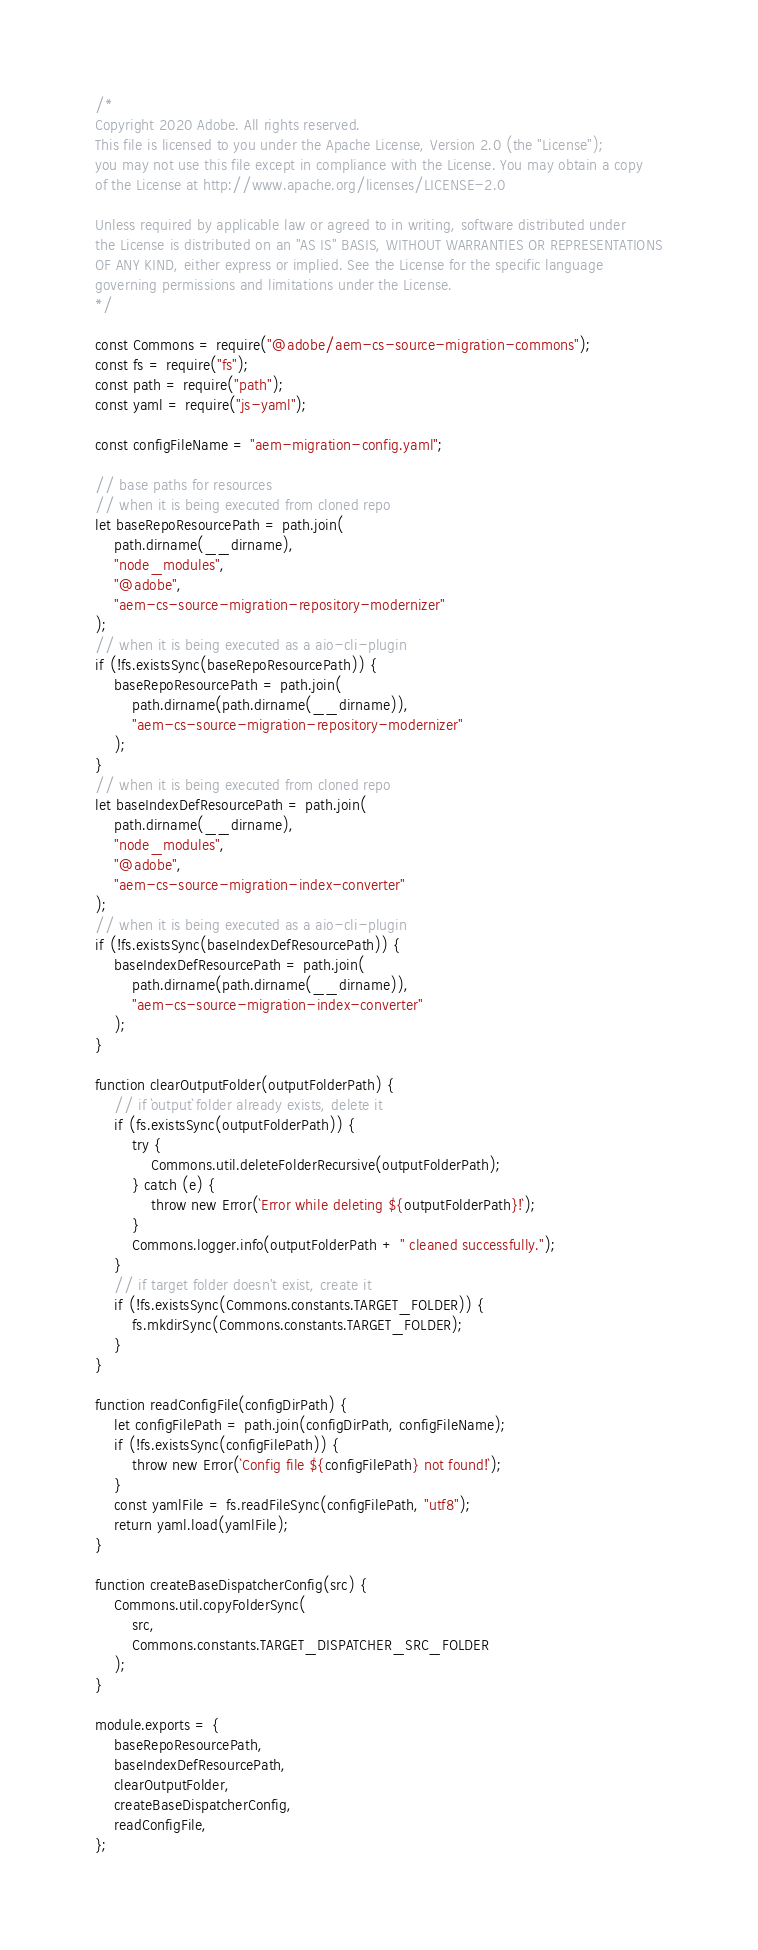Convert code to text. <code><loc_0><loc_0><loc_500><loc_500><_JavaScript_>/*
Copyright 2020 Adobe. All rights reserved.
This file is licensed to you under the Apache License, Version 2.0 (the "License");
you may not use this file except in compliance with the License. You may obtain a copy
of the License at http://www.apache.org/licenses/LICENSE-2.0

Unless required by applicable law or agreed to in writing, software distributed under
the License is distributed on an "AS IS" BASIS, WITHOUT WARRANTIES OR REPRESENTATIONS
OF ANY KIND, either express or implied. See the License for the specific language
governing permissions and limitations under the License.
*/

const Commons = require("@adobe/aem-cs-source-migration-commons");
const fs = require("fs");
const path = require("path");
const yaml = require("js-yaml");

const configFileName = "aem-migration-config.yaml";

// base paths for resources
// when it is being executed from cloned repo
let baseRepoResourcePath = path.join(
    path.dirname(__dirname),
    "node_modules",
    "@adobe",
    "aem-cs-source-migration-repository-modernizer"
);
// when it is being executed as a aio-cli-plugin
if (!fs.existsSync(baseRepoResourcePath)) {
    baseRepoResourcePath = path.join(
        path.dirname(path.dirname(__dirname)),
        "aem-cs-source-migration-repository-modernizer"
    );
}
// when it is being executed from cloned repo
let baseIndexDefResourcePath = path.join(
    path.dirname(__dirname),
    "node_modules",
    "@adobe",
    "aem-cs-source-migration-index-converter"
);
// when it is being executed as a aio-cli-plugin
if (!fs.existsSync(baseIndexDefResourcePath)) {
    baseIndexDefResourcePath = path.join(
        path.dirname(path.dirname(__dirname)),
        "aem-cs-source-migration-index-converter"
    );
}

function clearOutputFolder(outputFolderPath) {
    // if `output` folder already exists, delete it
    if (fs.existsSync(outputFolderPath)) {
        try {
            Commons.util.deleteFolderRecursive(outputFolderPath);
        } catch (e) {
            throw new Error(`Error while deleting ${outputFolderPath}!`);
        }
        Commons.logger.info(outputFolderPath + " cleaned successfully.");
    }
    // if target folder doesn't exist, create it
    if (!fs.existsSync(Commons.constants.TARGET_FOLDER)) {
        fs.mkdirSync(Commons.constants.TARGET_FOLDER);
    }
}

function readConfigFile(configDirPath) {
    let configFilePath = path.join(configDirPath, configFileName);
    if (!fs.existsSync(configFilePath)) {
        throw new Error(`Config file ${configFilePath} not found!`);
    }
    const yamlFile = fs.readFileSync(configFilePath, "utf8");
    return yaml.load(yamlFile);
}

function createBaseDispatcherConfig(src) {
    Commons.util.copyFolderSync(
        src,
        Commons.constants.TARGET_DISPATCHER_SRC_FOLDER
    );
}

module.exports = {
    baseRepoResourcePath,
    baseIndexDefResourcePath,
    clearOutputFolder,
    createBaseDispatcherConfig,
    readConfigFile,
};
</code> 